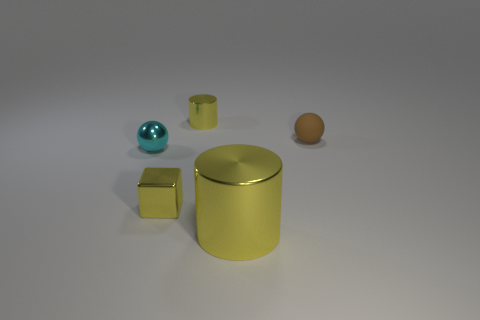There is a cube on the left side of the big thing; what number of balls are right of it?
Offer a very short reply. 1. How many cylinders are metal things or small cyan objects?
Provide a short and direct response. 2. There is a shiny object that is both behind the metal block and right of the tiny block; what is its color?
Ensure brevity in your answer.  Yellow. Are there any other things of the same color as the small shiny cube?
Offer a terse response. Yes. The cylinder behind the ball to the right of the small cylinder is what color?
Ensure brevity in your answer.  Yellow. Do the rubber ball and the cyan sphere have the same size?
Keep it short and to the point. Yes. Is the material of the cylinder that is in front of the brown sphere the same as the tiny sphere to the left of the tiny brown sphere?
Keep it short and to the point. Yes. The metal thing that is on the right side of the small yellow metal object that is behind the thing on the right side of the large cylinder is what shape?
Give a very brief answer. Cylinder. Are there more big red rubber spheres than brown spheres?
Provide a succinct answer. No. Is there a object?
Provide a short and direct response. Yes. 